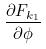Convert formula to latex. <formula><loc_0><loc_0><loc_500><loc_500>\frac { \partial F _ { k _ { 1 } } } { \partial \phi }</formula> 